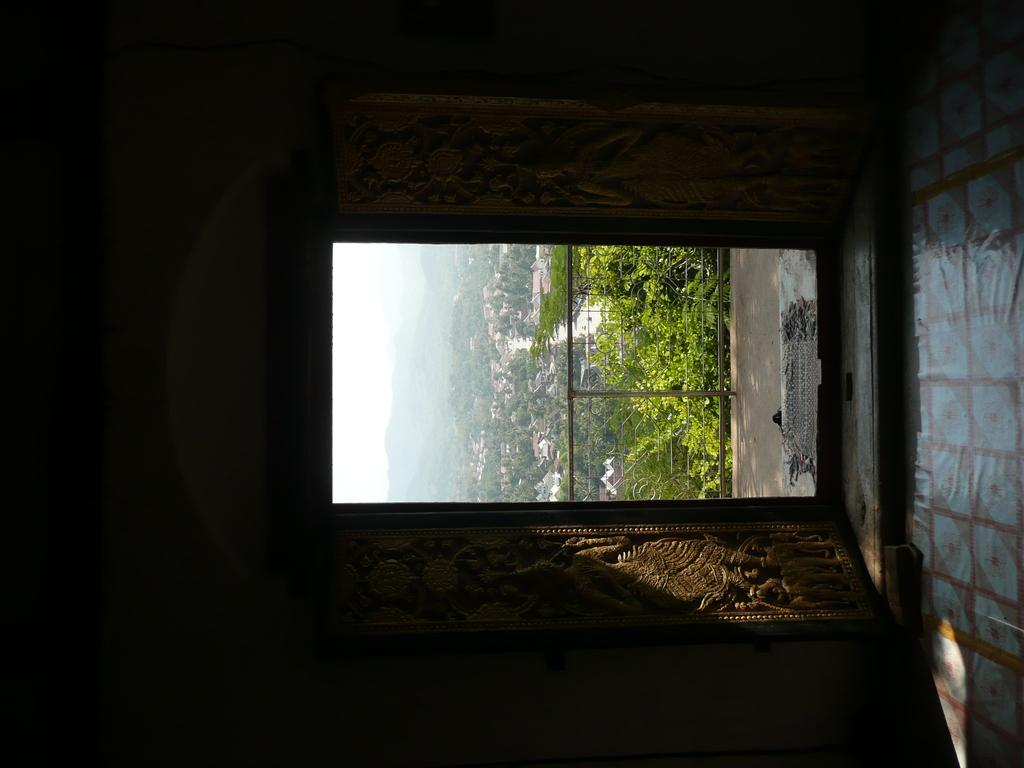What is the orientation of the image? The image is in the left direction. What can be seen on the right side of the image? There is a floor visible on the right side of the image. What type of location is depicted in the image? The image is an inside view of a room. What is visible outside of the room? There is a railing, trees, and buildings visible outside of the room. How does the room feel about the fifth person entering the room? The room does not have feelings, as it is an inanimate object. 